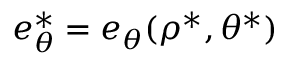<formula> <loc_0><loc_0><loc_500><loc_500>e _ { \theta } ^ { \ast } = e _ { \theta } ( \rho ^ { \ast } , \theta ^ { \ast } )</formula> 